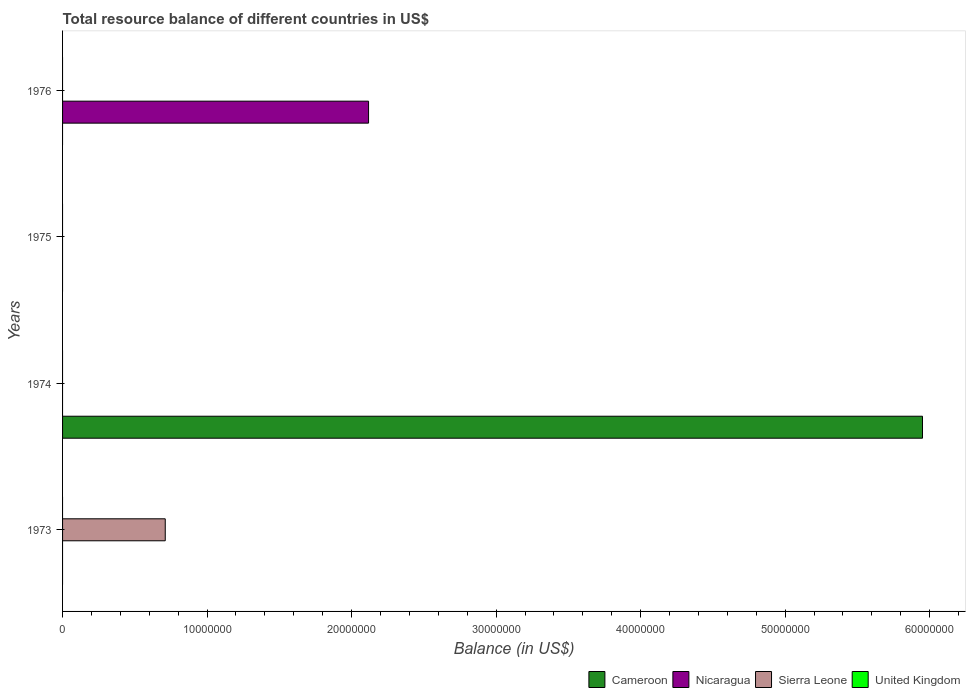Are the number of bars per tick equal to the number of legend labels?
Provide a succinct answer. No. Are the number of bars on each tick of the Y-axis equal?
Make the answer very short. No. How many bars are there on the 4th tick from the top?
Offer a very short reply. 1. How many bars are there on the 1st tick from the bottom?
Ensure brevity in your answer.  1. What is the label of the 3rd group of bars from the top?
Your response must be concise. 1974. What is the total resource balance in United Kingdom in 1974?
Give a very brief answer. 0. Across all years, what is the maximum total resource balance in Sierra Leone?
Give a very brief answer. 7.10e+06. In which year was the total resource balance in Sierra Leone maximum?
Offer a very short reply. 1973. What is the total total resource balance in Cameroon in the graph?
Offer a very short reply. 5.95e+07. What is the difference between the total resource balance in Sierra Leone in 1976 and the total resource balance in Cameroon in 1974?
Give a very brief answer. -5.95e+07. What is the average total resource balance in United Kingdom per year?
Keep it short and to the point. 0. In how many years, is the total resource balance in Nicaragua greater than 54000000 US$?
Offer a terse response. 0. What is the difference between the highest and the lowest total resource balance in Nicaragua?
Your response must be concise. 2.12e+07. Is it the case that in every year, the sum of the total resource balance in Sierra Leone and total resource balance in Nicaragua is greater than the sum of total resource balance in Cameroon and total resource balance in United Kingdom?
Offer a very short reply. No. Are the values on the major ticks of X-axis written in scientific E-notation?
Your answer should be compact. No. Does the graph contain any zero values?
Provide a succinct answer. Yes. How are the legend labels stacked?
Ensure brevity in your answer.  Horizontal. What is the title of the graph?
Provide a succinct answer. Total resource balance of different countries in US$. What is the label or title of the X-axis?
Provide a short and direct response. Balance (in US$). What is the Balance (in US$) in Nicaragua in 1973?
Your response must be concise. 0. What is the Balance (in US$) in Sierra Leone in 1973?
Keep it short and to the point. 7.10e+06. What is the Balance (in US$) in United Kingdom in 1973?
Provide a short and direct response. 0. What is the Balance (in US$) in Cameroon in 1974?
Provide a short and direct response. 5.95e+07. What is the Balance (in US$) in United Kingdom in 1974?
Offer a very short reply. 0. What is the Balance (in US$) of Cameroon in 1975?
Provide a short and direct response. 0. What is the Balance (in US$) in Sierra Leone in 1975?
Offer a terse response. 0. What is the Balance (in US$) of United Kingdom in 1975?
Your answer should be compact. 0. What is the Balance (in US$) in Nicaragua in 1976?
Your answer should be very brief. 2.12e+07. What is the Balance (in US$) in United Kingdom in 1976?
Ensure brevity in your answer.  0. Across all years, what is the maximum Balance (in US$) of Cameroon?
Provide a succinct answer. 5.95e+07. Across all years, what is the maximum Balance (in US$) in Nicaragua?
Provide a short and direct response. 2.12e+07. Across all years, what is the maximum Balance (in US$) of Sierra Leone?
Give a very brief answer. 7.10e+06. Across all years, what is the minimum Balance (in US$) of Cameroon?
Your answer should be compact. 0. Across all years, what is the minimum Balance (in US$) in Nicaragua?
Provide a succinct answer. 0. What is the total Balance (in US$) in Cameroon in the graph?
Your response must be concise. 5.95e+07. What is the total Balance (in US$) of Nicaragua in the graph?
Make the answer very short. 2.12e+07. What is the total Balance (in US$) of Sierra Leone in the graph?
Your answer should be compact. 7.10e+06. What is the difference between the Balance (in US$) in Cameroon in 1974 and the Balance (in US$) in Nicaragua in 1976?
Your answer should be very brief. 3.83e+07. What is the average Balance (in US$) of Cameroon per year?
Make the answer very short. 1.49e+07. What is the average Balance (in US$) in Nicaragua per year?
Provide a succinct answer. 5.29e+06. What is the average Balance (in US$) of Sierra Leone per year?
Offer a very short reply. 1.78e+06. What is the average Balance (in US$) of United Kingdom per year?
Your answer should be very brief. 0. What is the difference between the highest and the lowest Balance (in US$) of Cameroon?
Offer a terse response. 5.95e+07. What is the difference between the highest and the lowest Balance (in US$) in Nicaragua?
Provide a succinct answer. 2.12e+07. What is the difference between the highest and the lowest Balance (in US$) in Sierra Leone?
Keep it short and to the point. 7.10e+06. 